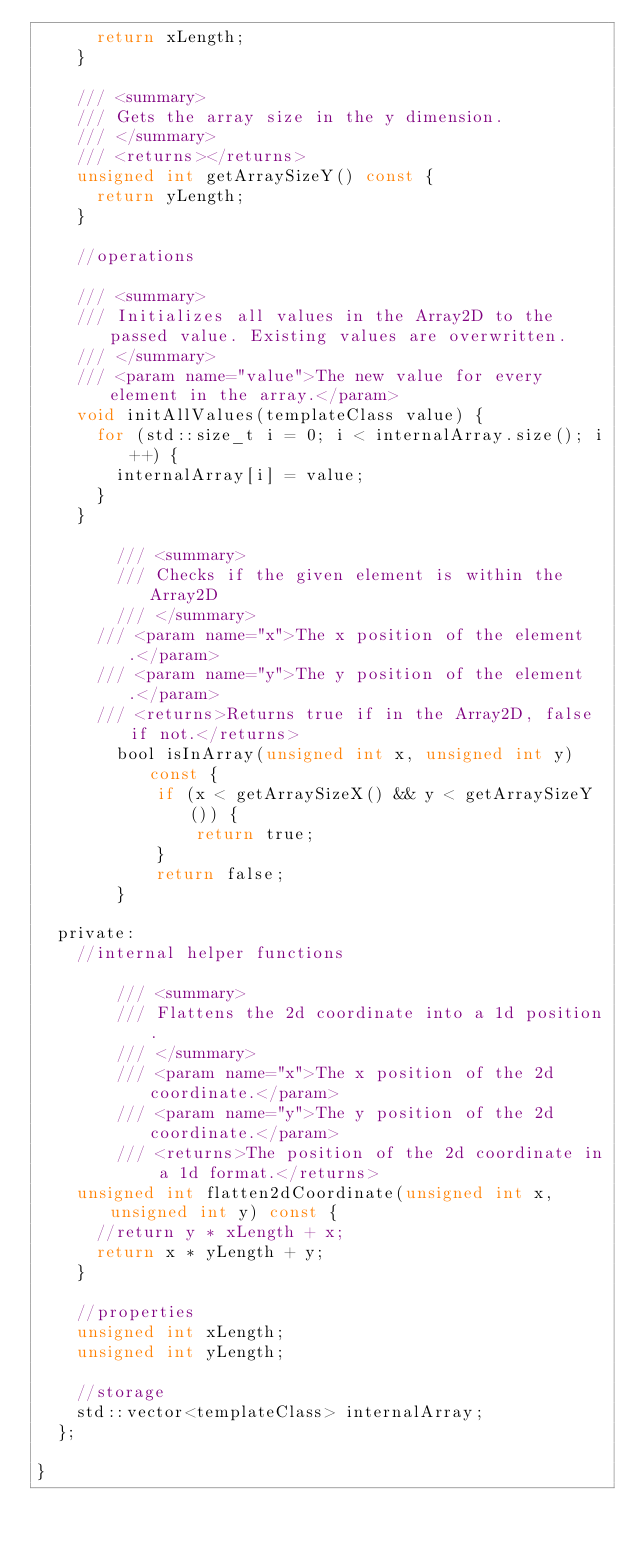<code> <loc_0><loc_0><loc_500><loc_500><_C_>			return xLength;
		}

		/// <summary>
		/// Gets the array size in the y dimension.
		/// </summary>
		/// <returns></returns>
		unsigned int getArraySizeY() const {
			return yLength;
		}

		//operations

		/// <summary>
		/// Initializes all values in the Array2D to the passed value. Existing values are overwritten.
		/// </summary>
		/// <param name="value">The new value for every element in the array.</param>
		void initAllValues(templateClass value) {
			for (std::size_t i = 0; i < internalArray.size(); i++) {
				internalArray[i] = value;
			}
		}

        /// <summary>
        /// Checks if the given element is within the Array2D
        /// </summary>
	    /// <param name="x">The x position of the element.</param>
	    /// <param name="y">The y position of the element.</param>
	    /// <returns>Returns true if in the Array2D, false if not.</returns>
        bool isInArray(unsigned int x, unsigned int y) const {
            if (x < getArraySizeX() && y < getArraySizeY()) {
                return true;
            }
            return false;
        }

	private:
		//internal helper functions

        /// <summary>
        /// Flattens the 2d coordinate into a 1d position.
        /// </summary>
        /// <param name="x">The x position of the 2d coordinate.</param>
        /// <param name="y">The y position of the 2d coordinate.</param>
        /// <returns>The position of the 2d coordinate in a 1d format.</returns>
		unsigned int flatten2dCoordinate(unsigned int x, unsigned int y) const {
			//return y * xLength + x;
			return x * yLength + y;
		}

		//properties
		unsigned int xLength;
		unsigned int yLength;

		//storage
		std::vector<templateClass> internalArray;
	};

}
</code> 